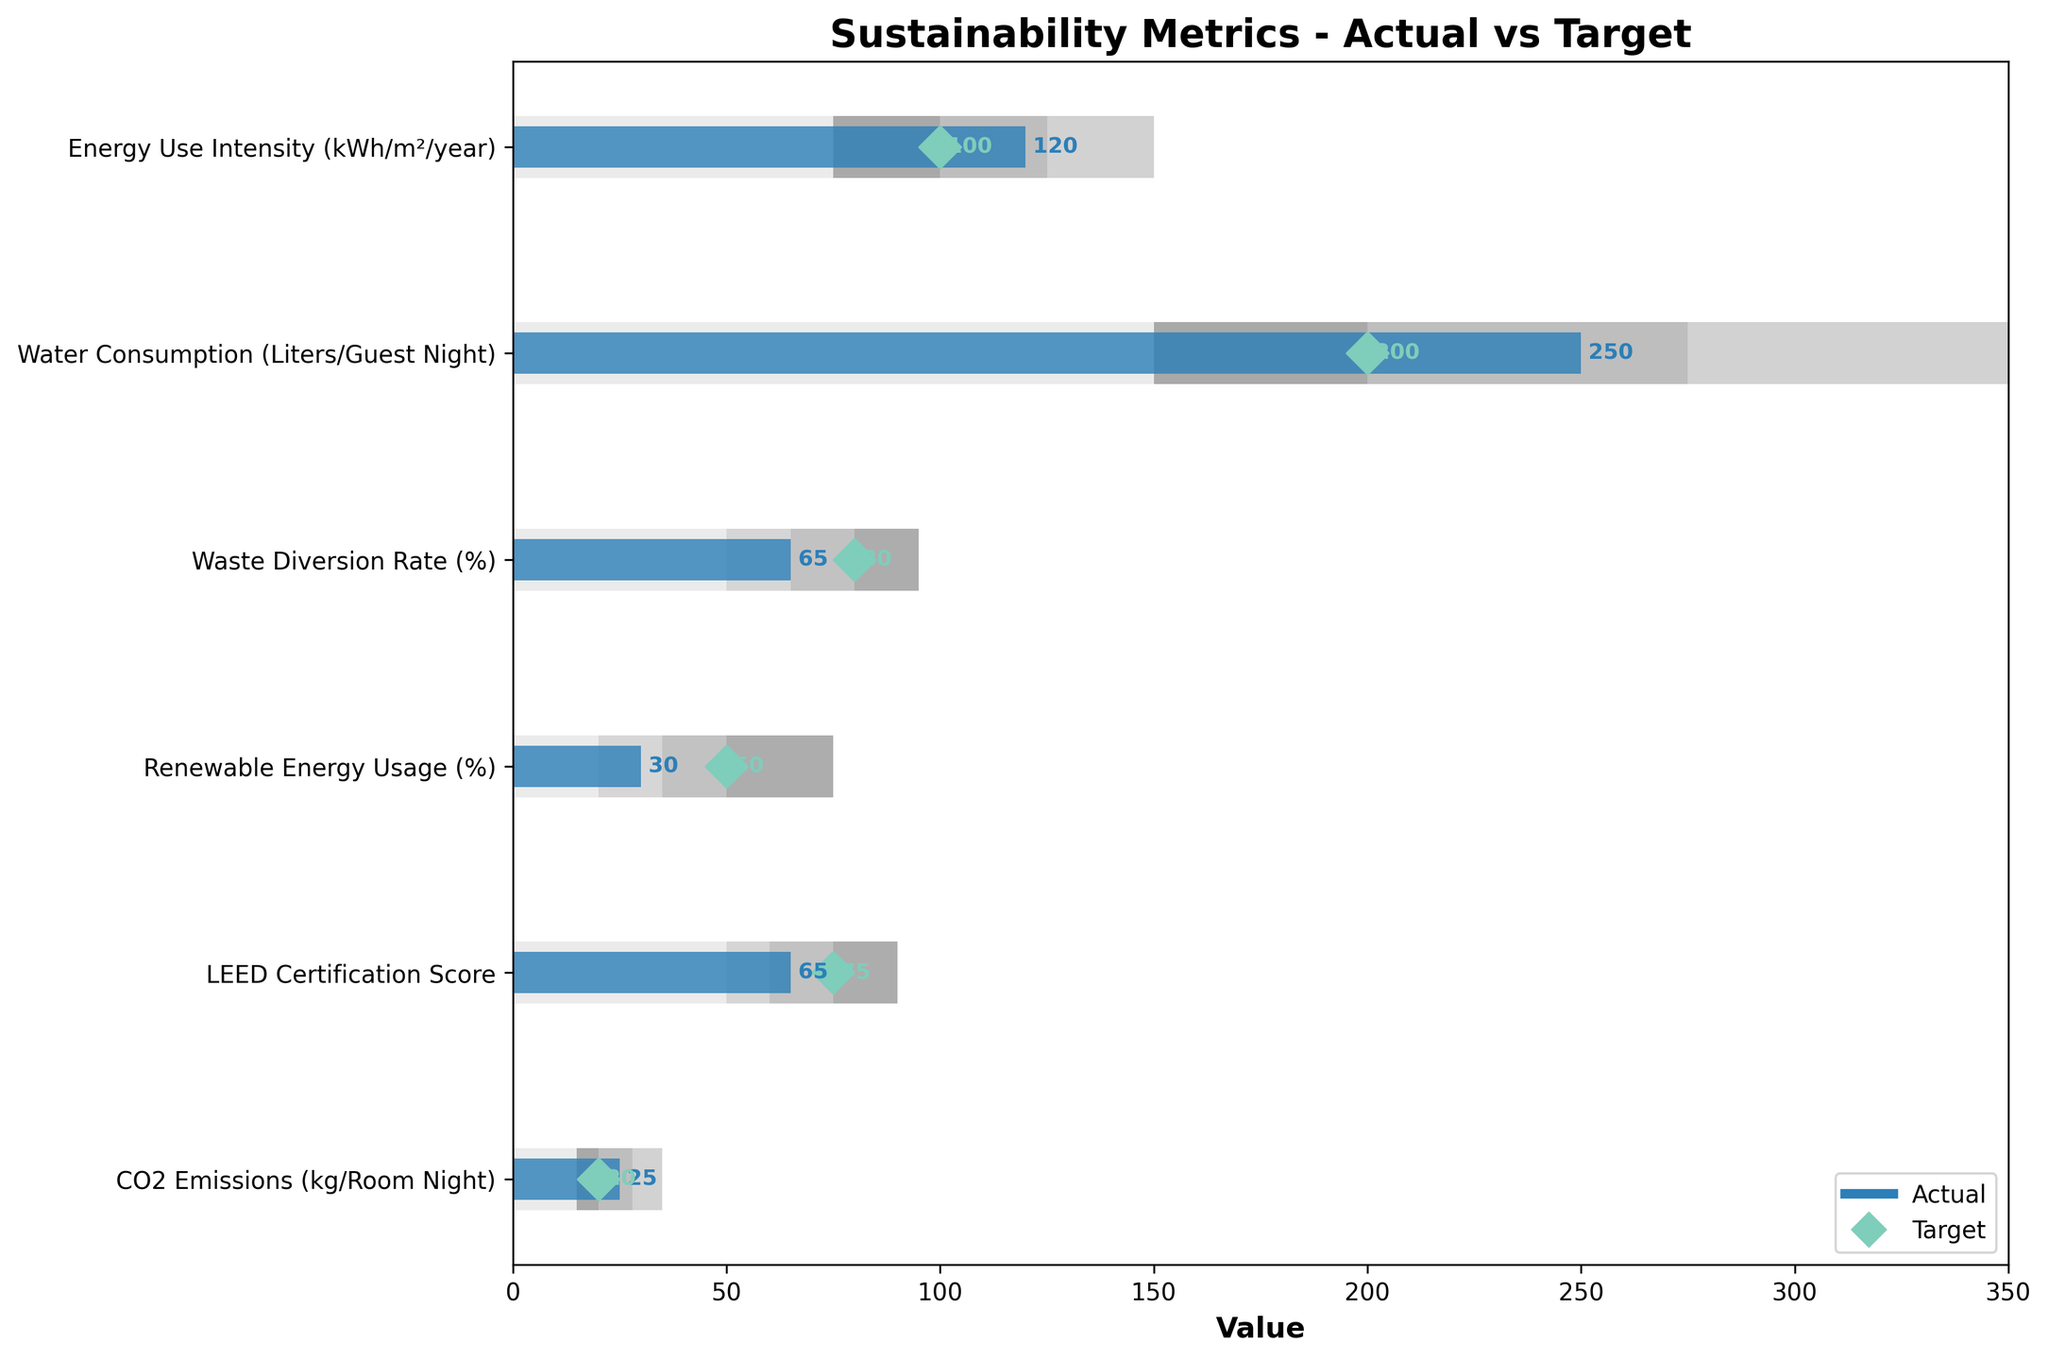What is the actual value for Energy Use Intensity (kWh/m²/year)? The actual value for Energy Use Intensity (kWh/m²/year) is the length of the blue bar in the Energy Use Intensity row.
Answer: 120 Which metric has the highest target value? To find the metric with the highest target value, we look at the green diamond markers and identify the one furthest to the right.
Answer: Water Consumption (Liters/Guest Night) What is the difference between the actual and target values for CO2 Emissions (kg/Room Night)? The actual value for CO2 Emissions is 25, and the target value is 20. The difference is calculated as 25 - 20.
Answer: 5 How does the actual water consumption compare to its satisfactory range? The actual water consumption is 250, which is within the Poor range (between 200 and 350). This is above the Satisfactory range, which ends at 275.
Answer: Above Satisfactory Which metric is closest to achieving its target value? To determine the closest metric, we compare the differences between the actual values and target values for each metric. The smallest difference will indicate the closest metric.
Answer: CO2 Emissions (kg/Room Night) Between Renewable Energy Usage (%) and LEED Certification Score, which metric's actual value is further from its target? The difference for Renewable Energy Usage is 50 - 30 = 20. The difference for LEED Certification Score is 75 - 65 = 10. Thus, Renewable Energy Usage is further from its target.
Answer: Renewable Energy Usage (%) What is the maximum value in the Poor range for Waste Diversion Rate (%)? The Poor range for Waste Diversion Rate (%) is from 50 to 65, so the maximum value in the Poor range is 65.
Answer: 65 In which range does the actual value of Energy Use Intensity (kWh/m²/year) fall? The actual value of Energy Use Intensity is 120. The ranges are Poor (150-125), Satisfactory (125-100), Good (100-75). Since 120 is between 125 and 100, it falls in the Satisfactory range.
Answer: Satisfactory For which metrics are the actual values better than the target values? We compare the actual values to the target values for each metric and identify those where the actual value is lower (better since lower values are favorable for these metrics).
Answer: None What are the excellent ranges for the metrics? The excellent ranges are as follows: Energy Use Intensity (<75), Water Consumption (<150), Waste Diversion Rate (>80), Renewable Energy Usage (>75), LEED Certification Score (>90), CO2 Emissions (<15).
Answer: Energy Use Intensity: <75, Water Consumption: <150, Waste Diversion Rate: >80, Renewable Energy Usage: >75, LEED Certification Score: >90, CO2 Emissions: <15 